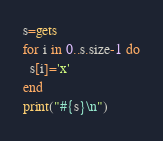<code> <loc_0><loc_0><loc_500><loc_500><_Ruby_>s=gets
for i in 0..s.size-1 do
  s[i]='x'
end
print("#{s}\n")</code> 